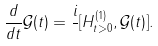Convert formula to latex. <formula><loc_0><loc_0><loc_500><loc_500>\frac { d } { d t } \mathcal { G } ( t ) = \frac { i } { } [ H _ { t > 0 } ^ { ( 1 ) } , \mathcal { G } ( t ) ] .</formula> 